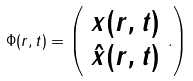Convert formula to latex. <formula><loc_0><loc_0><loc_500><loc_500>\Phi ( r , t ) = \left ( \begin{array} { c } x ( r , t ) \\ { \hat { x } } ( r , t ) \end{array} . \right )</formula> 